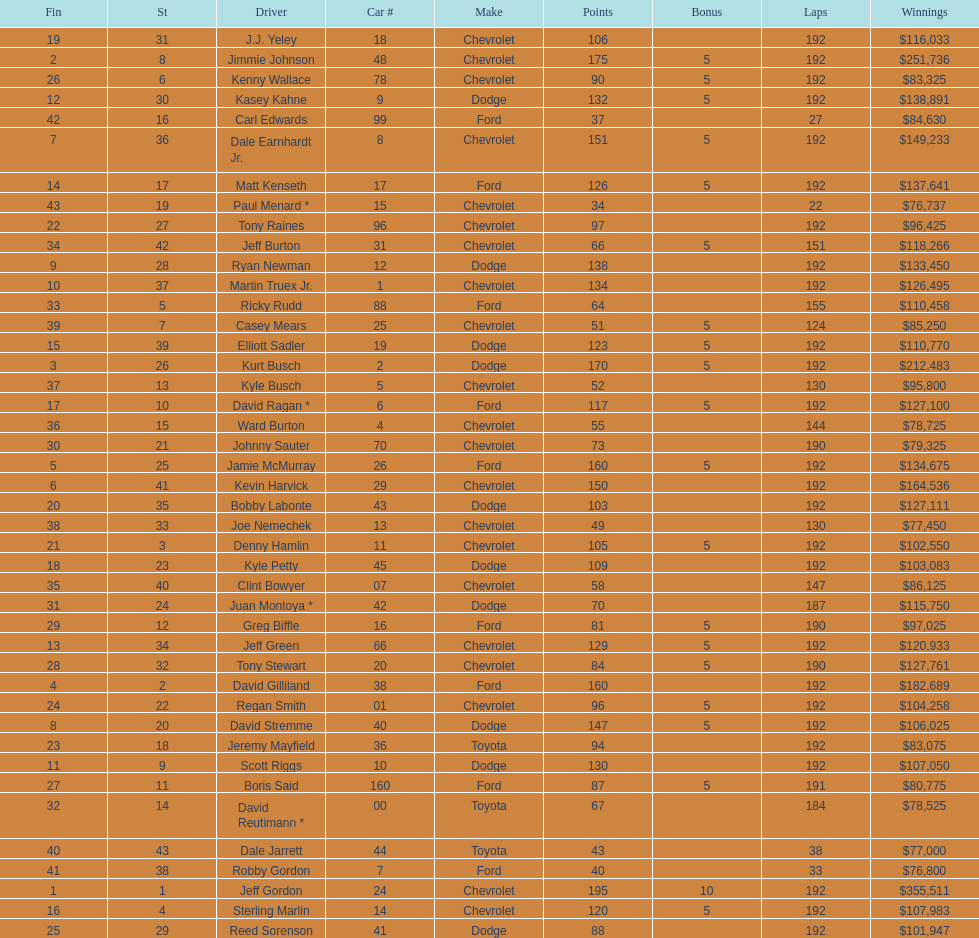What type of race car was driven by both jeff gordon and jimmie johnson? Chevrolet. 